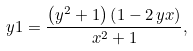Convert formula to latex. <formula><loc_0><loc_0><loc_500><loc_500>\ y 1 = { \frac { \left ( { y } ^ { 2 } + 1 \right ) \left ( 1 - 2 \, y x \right ) } { { x } ^ { 2 } + 1 } } ,</formula> 